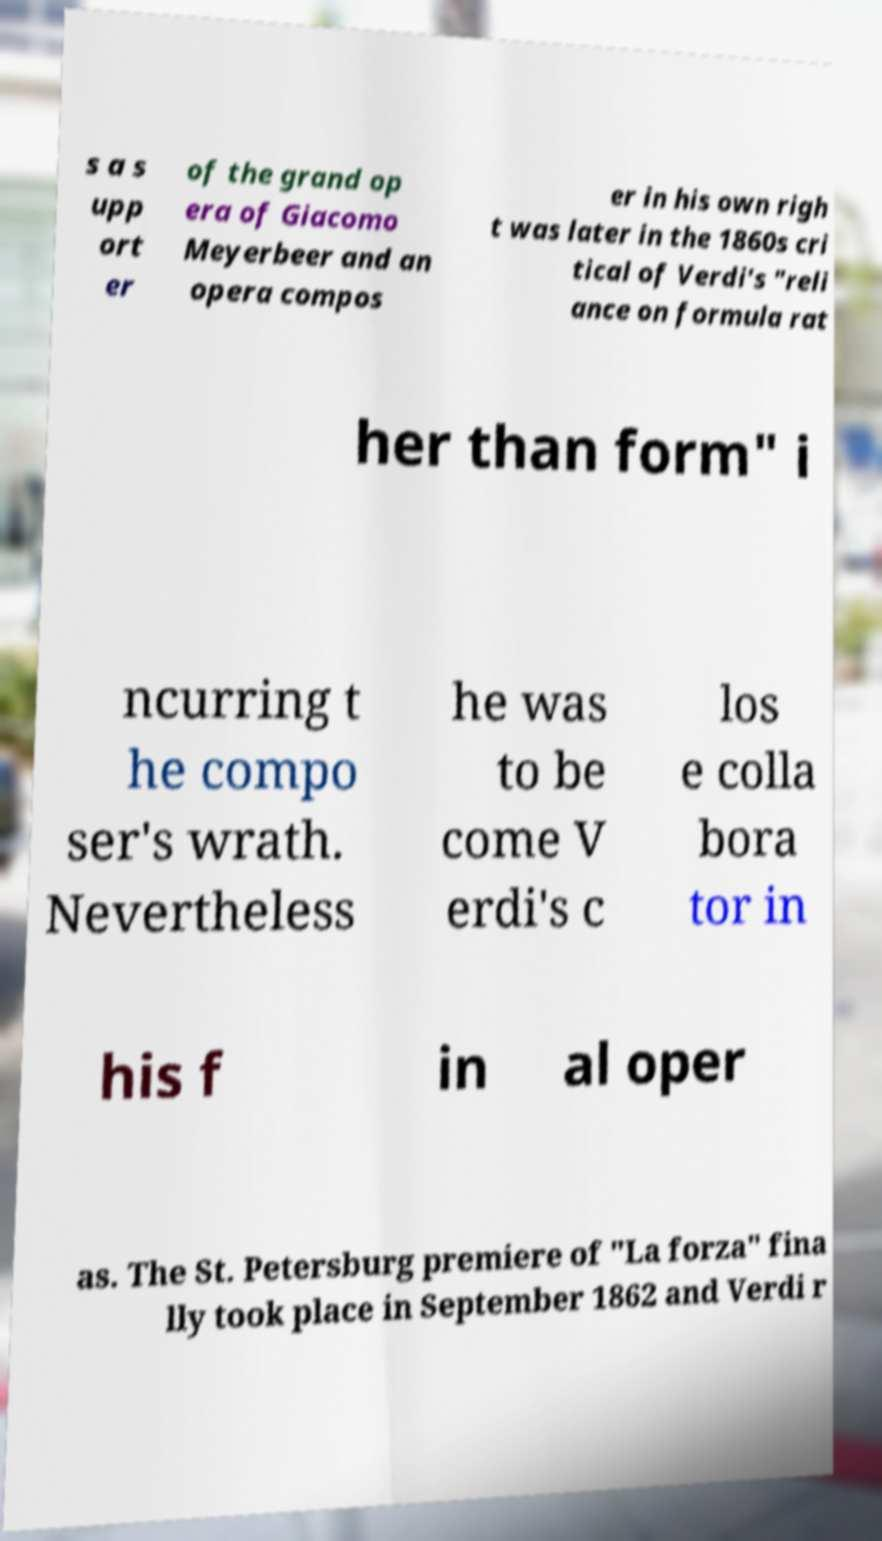There's text embedded in this image that I need extracted. Can you transcribe it verbatim? s a s upp ort er of the grand op era of Giacomo Meyerbeer and an opera compos er in his own righ t was later in the 1860s cri tical of Verdi's "reli ance on formula rat her than form" i ncurring t he compo ser's wrath. Nevertheless he was to be come V erdi's c los e colla bora tor in his f in al oper as. The St. Petersburg premiere of "La forza" fina lly took place in September 1862 and Verdi r 